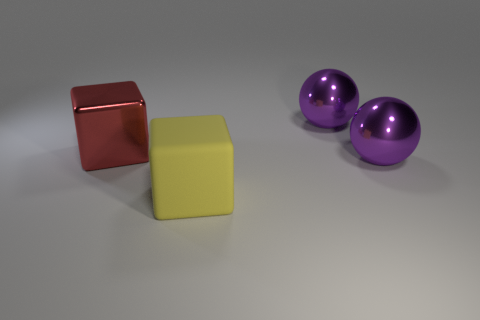Add 2 matte blocks. How many objects exist? 6 Add 1 yellow rubber objects. How many yellow rubber objects are left? 2 Add 2 big yellow objects. How many big yellow objects exist? 3 Subtract 2 purple spheres. How many objects are left? 2 Subtract all tiny metallic things. Subtract all large yellow blocks. How many objects are left? 3 